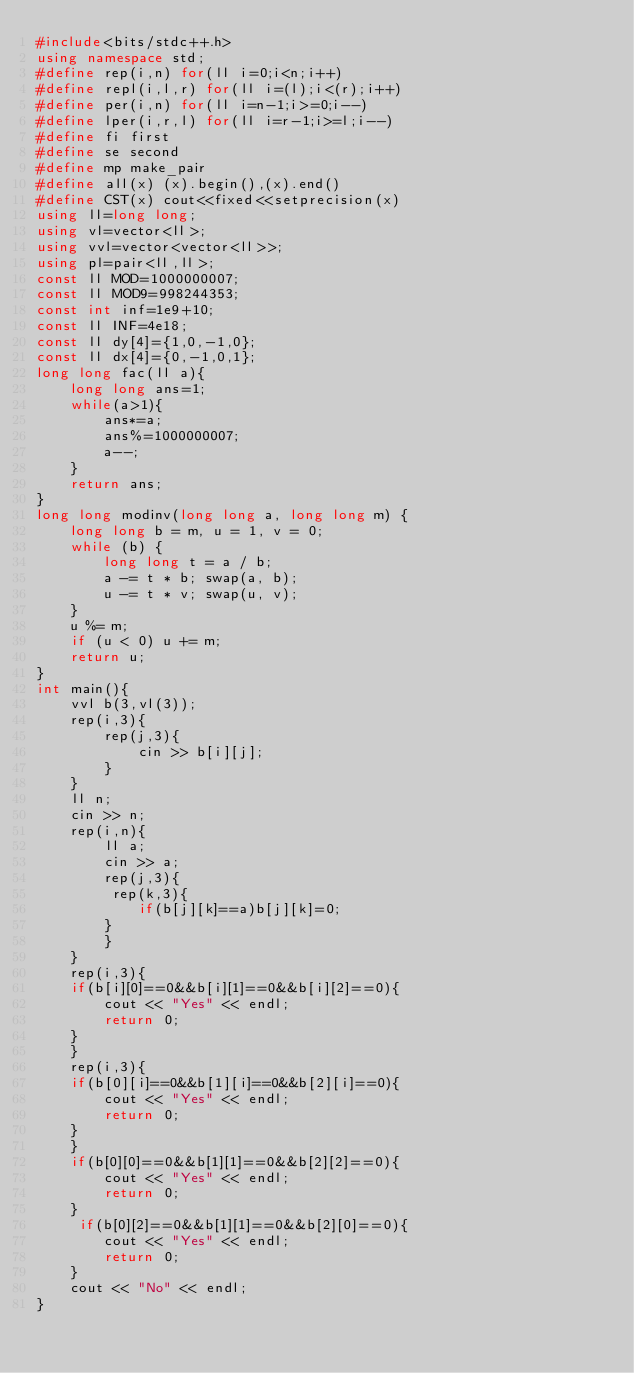<code> <loc_0><loc_0><loc_500><loc_500><_C++_>#include<bits/stdc++.h>
using namespace std;
#define rep(i,n) for(ll i=0;i<n;i++)
#define repl(i,l,r) for(ll i=(l);i<(r);i++)
#define per(i,n) for(ll i=n-1;i>=0;i--)
#define lper(i,r,l) for(ll i=r-1;i>=l;i--)
#define fi first
#define se second
#define mp make_pair
#define all(x) (x).begin(),(x).end()
#define CST(x) cout<<fixed<<setprecision(x)
using ll=long long;
using vl=vector<ll>;
using vvl=vector<vector<ll>>;
using pl=pair<ll,ll>;
const ll MOD=1000000007;
const ll MOD9=998244353;
const int inf=1e9+10;
const ll INF=4e18;
const ll dy[4]={1,0,-1,0};
const ll dx[4]={0,-1,0,1};
long long fac(ll a){
    long long ans=1;
    while(a>1){
        ans*=a;
        ans%=1000000007;
        a--;
    }
    return ans;
}
long long modinv(long long a, long long m) {
    long long b = m, u = 1, v = 0;
    while (b) {
        long long t = a / b;
        a -= t * b; swap(a, b);
        u -= t * v; swap(u, v);
    }
    u %= m; 
    if (u < 0) u += m;
    return u;
}
int main(){
    vvl b(3,vl(3));
    rep(i,3){
        rep(j,3){
            cin >> b[i][j];
        }
    }
    ll n;
    cin >> n;
    rep(i,n){
        ll a;
        cin >> a;
        rep(j,3){
         rep(k,3){
            if(b[j][k]==a)b[j][k]=0;
        }
        }
    }
    rep(i,3){
    if(b[i][0]==0&&b[i][1]==0&&b[i][2]==0){
        cout << "Yes" << endl;
        return 0;
    }
    }
    rep(i,3){
    if(b[0][i]==0&&b[1][i]==0&&b[2][i]==0){
        cout << "Yes" << endl;
        return 0;
    }
    }
    if(b[0][0]==0&&b[1][1]==0&&b[2][2]==0){
        cout << "Yes" << endl;
        return 0;
    }
     if(b[0][2]==0&&b[1][1]==0&&b[2][0]==0){
        cout << "Yes" << endl;
        return 0;
    }
    cout << "No" << endl;
}
    </code> 